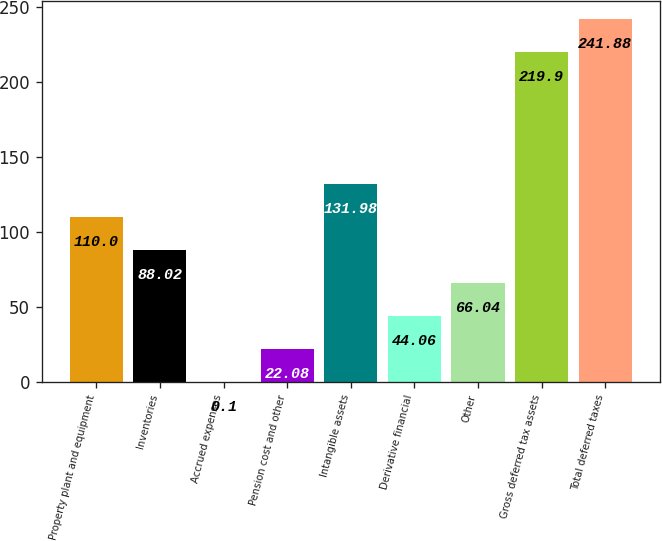<chart> <loc_0><loc_0><loc_500><loc_500><bar_chart><fcel>Property plant and equipment<fcel>Inventories<fcel>Accrued expenses<fcel>Pension cost and other<fcel>Intangible assets<fcel>Derivative financial<fcel>Other<fcel>Gross deferred tax assets<fcel>Total deferred taxes<nl><fcel>110<fcel>88.02<fcel>0.1<fcel>22.08<fcel>131.98<fcel>44.06<fcel>66.04<fcel>219.9<fcel>241.88<nl></chart> 